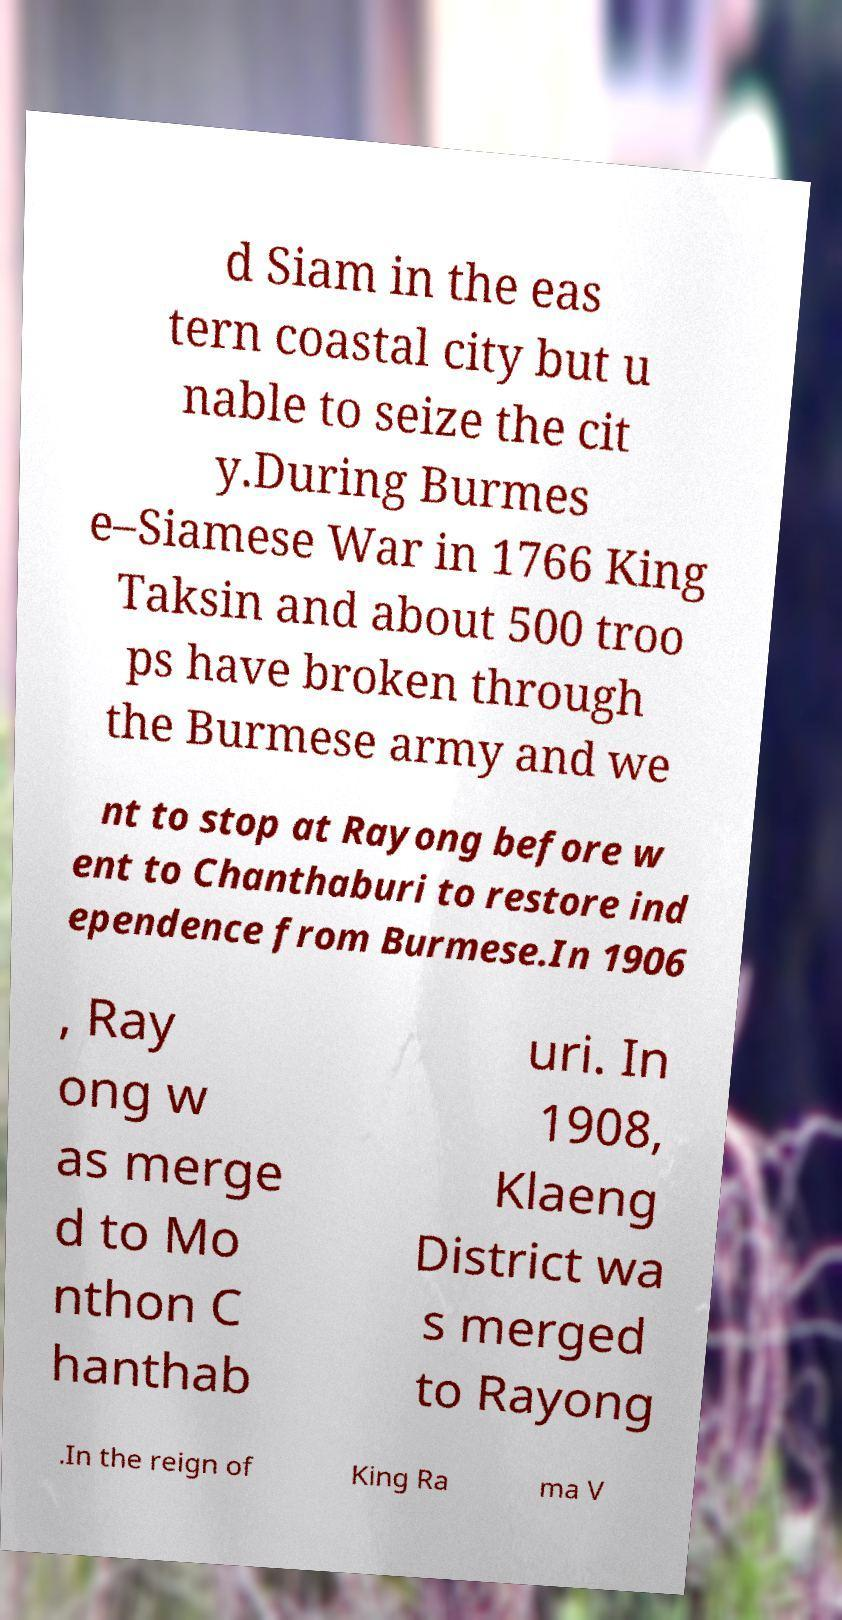Can you read and provide the text displayed in the image?This photo seems to have some interesting text. Can you extract and type it out for me? d Siam in the eas tern coastal city but u nable to seize the cit y.During Burmes e–Siamese War in 1766 King Taksin and about 500 troo ps have broken through the Burmese army and we nt to stop at Rayong before w ent to Chanthaburi to restore ind ependence from Burmese.In 1906 , Ray ong w as merge d to Mo nthon C hanthab uri. In 1908, Klaeng District wa s merged to Rayong .In the reign of King Ra ma V 